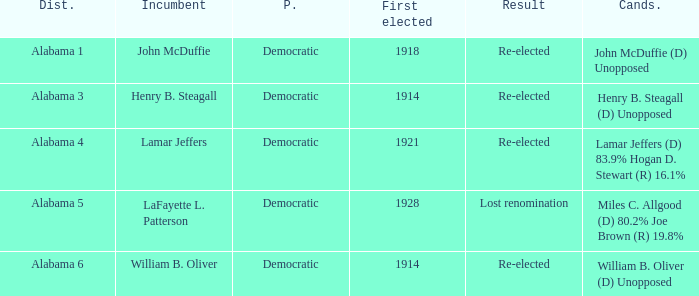What kind of party is the district in Alabama 1? Democratic. 